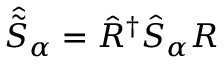<formula> <loc_0><loc_0><loc_500><loc_500>\hat { \tilde { S } } _ { \alpha } = \hat { R } ^ { \dagger } \hat { S } _ { \alpha } R</formula> 